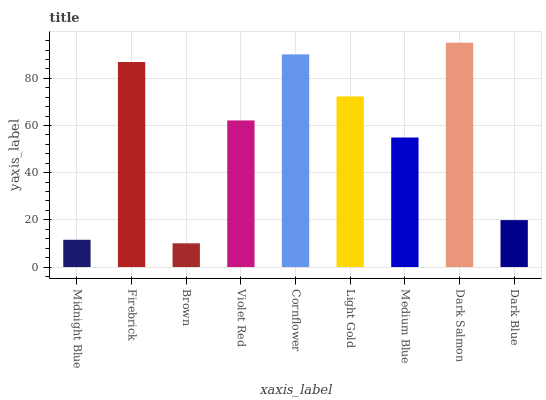Is Brown the minimum?
Answer yes or no. Yes. Is Dark Salmon the maximum?
Answer yes or no. Yes. Is Firebrick the minimum?
Answer yes or no. No. Is Firebrick the maximum?
Answer yes or no. No. Is Firebrick greater than Midnight Blue?
Answer yes or no. Yes. Is Midnight Blue less than Firebrick?
Answer yes or no. Yes. Is Midnight Blue greater than Firebrick?
Answer yes or no. No. Is Firebrick less than Midnight Blue?
Answer yes or no. No. Is Violet Red the high median?
Answer yes or no. Yes. Is Violet Red the low median?
Answer yes or no. Yes. Is Dark Blue the high median?
Answer yes or no. No. Is Dark Blue the low median?
Answer yes or no. No. 